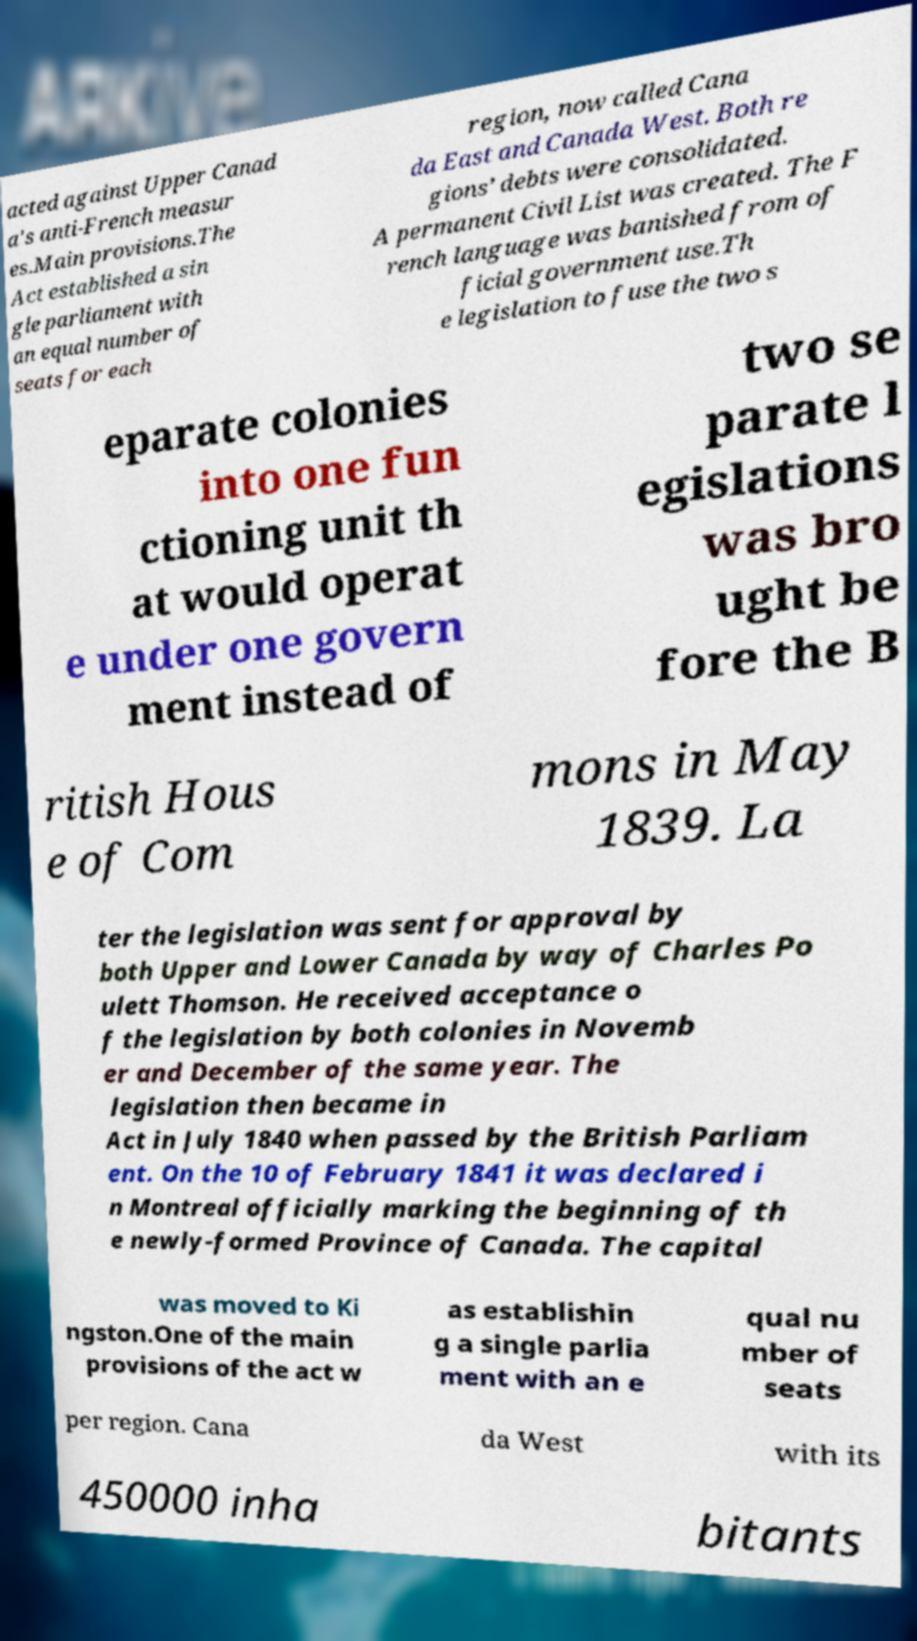There's text embedded in this image that I need extracted. Can you transcribe it verbatim? acted against Upper Canad a's anti-French measur es.Main provisions.The Act established a sin gle parliament with an equal number of seats for each region, now called Cana da East and Canada West. Both re gions’ debts were consolidated. A permanent Civil List was created. The F rench language was banished from of ficial government use.Th e legislation to fuse the two s eparate colonies into one fun ctioning unit th at would operat e under one govern ment instead of two se parate l egislations was bro ught be fore the B ritish Hous e of Com mons in May 1839. La ter the legislation was sent for approval by both Upper and Lower Canada by way of Charles Po ulett Thomson. He received acceptance o f the legislation by both colonies in Novemb er and December of the same year. The legislation then became in Act in July 1840 when passed by the British Parliam ent. On the 10 of February 1841 it was declared i n Montreal officially marking the beginning of th e newly-formed Province of Canada. The capital was moved to Ki ngston.One of the main provisions of the act w as establishin g a single parlia ment with an e qual nu mber of seats per region. Cana da West with its 450000 inha bitants 